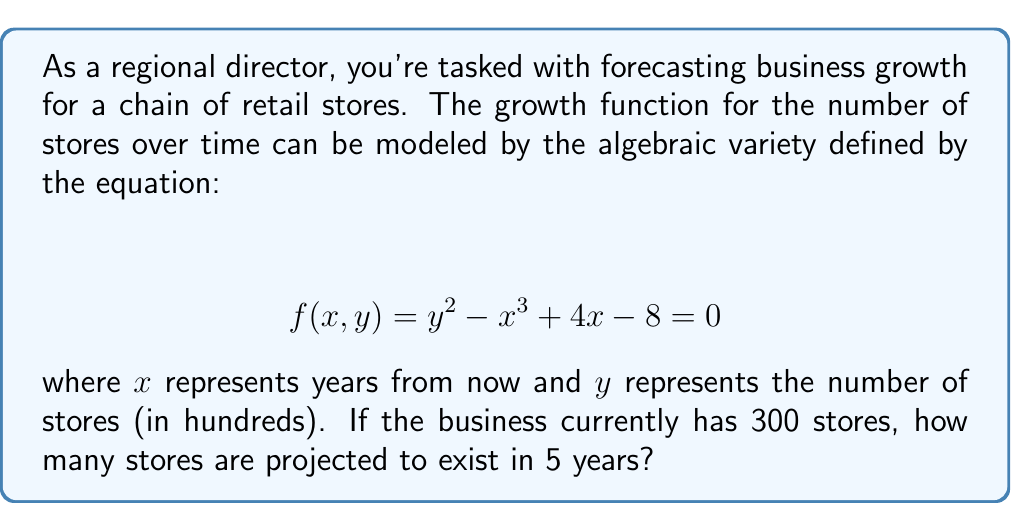Can you answer this question? 1) We start with the given algebraic variety equation:
   $$ f(x,y) = y^2 - x^3 + 4x - 8 = 0 $$

2) We know that currently (x = 0), there are 300 stores, which is 3 in our scale of hundreds. So, y = 3 when x = 0.

3) To find the number of stores in 5 years, we need to solve for y when x = 5:
   $$ y^2 - 5^3 + 4(5) - 8 = 0 $$

4) Simplify:
   $$ y^2 - 125 + 20 - 8 = 0 $$
   $$ y^2 - 113 = 0 $$

5) Solve for y:
   $$ y^2 = 113 $$
   $$ y = \pm \sqrt{113} $$

6) Since we're dealing with a number of stores, we only consider the positive solution:
   $$ y = \sqrt{113} $$

7) Remember that y represents hundreds of stores, so we multiply by 100:
   $$ \text{Number of stores} = 100 \cdot \sqrt{113} \approx 1062.87 $$

8) Rounding to the nearest whole number of stores:
   $$ \text{Number of stores} \approx 1063 $$
Answer: 1063 stores 